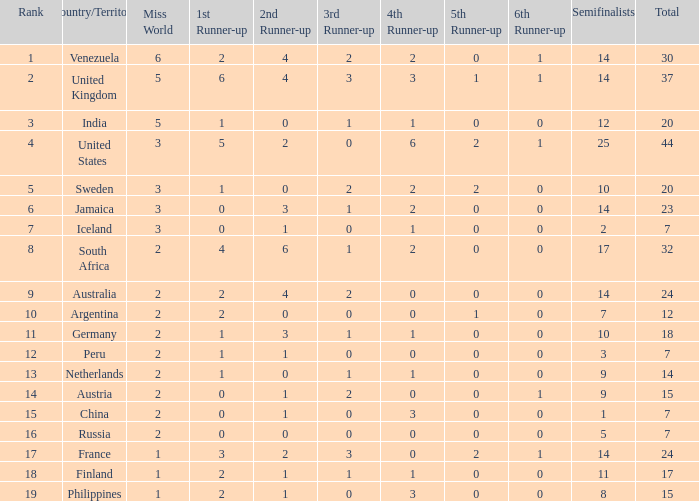What is the total position of venezuela in the ranking? 30.0. 